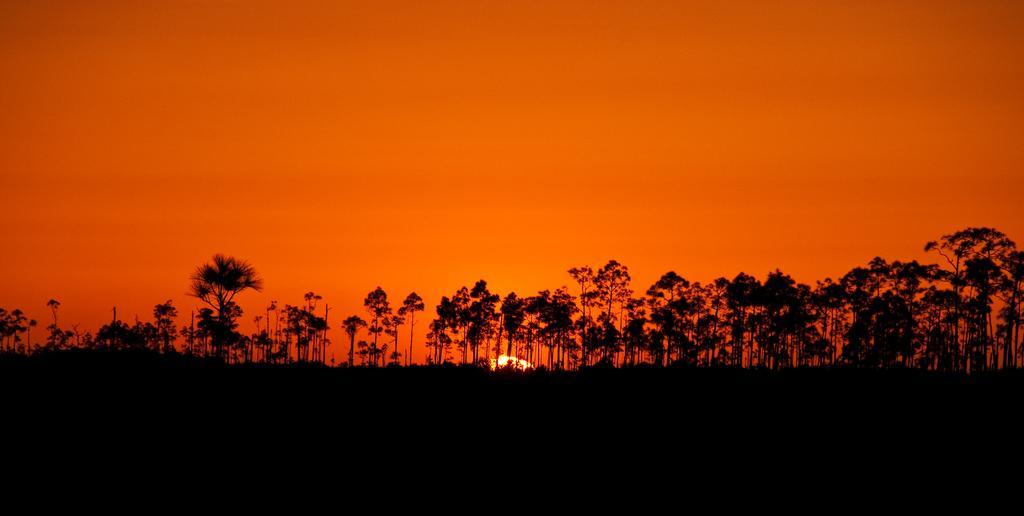Can you describe this image briefly? At the bottom of the image it is dark. In this image there are trees, sun and sky. 